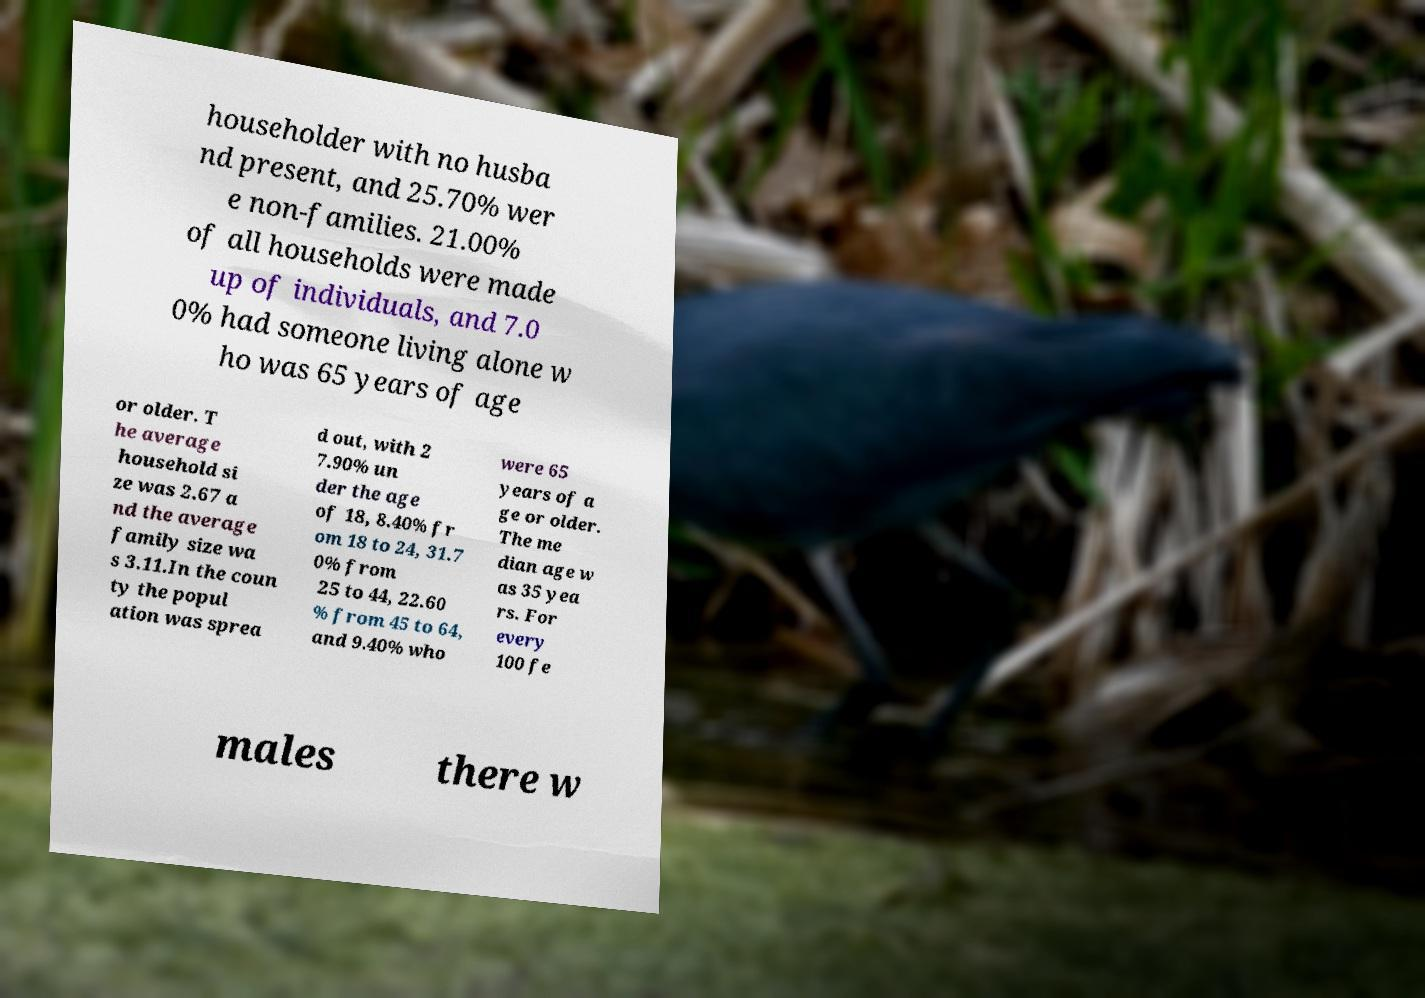Could you assist in decoding the text presented in this image and type it out clearly? householder with no husba nd present, and 25.70% wer e non-families. 21.00% of all households were made up of individuals, and 7.0 0% had someone living alone w ho was 65 years of age or older. T he average household si ze was 2.67 a nd the average family size wa s 3.11.In the coun ty the popul ation was sprea d out, with 2 7.90% un der the age of 18, 8.40% fr om 18 to 24, 31.7 0% from 25 to 44, 22.60 % from 45 to 64, and 9.40% who were 65 years of a ge or older. The me dian age w as 35 yea rs. For every 100 fe males there w 